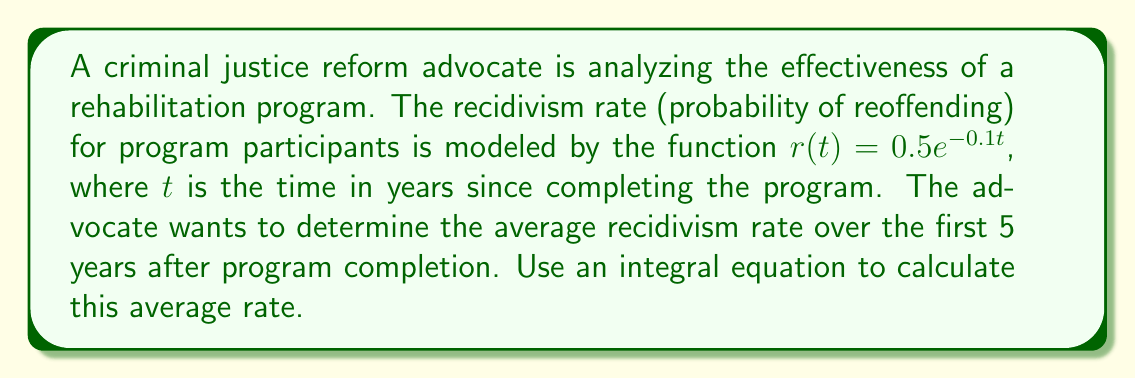Can you solve this math problem? To solve this problem, we need to use the concept of average value of a function over an interval. The formula for the average value of a function $f(x)$ over an interval $[a,b]$ is:

$$\text{Average} = \frac{1}{b-a} \int_a^b f(x) dx$$

In our case:
1) The function is $r(t) = 0.5e^{-0.1t}$
2) The interval is $[0,5]$ (5 years)

Let's set up the integral equation:

$$\text{Average recidivism rate} = \frac{1}{5-0} \int_0^5 0.5e^{-0.1t} dt$$

Now, let's solve the integral:

$$\begin{align}
\frac{1}{5} \int_0^5 0.5e^{-0.1t} dt &= \frac{1}{5} \cdot 0.5 \int_0^5 e^{-0.1t} dt \\
&= \frac{1}{10} \left[ -10e^{-0.1t} \right]_0^5 \\
&= \frac{1}{10} \left[ (-10e^{-0.5}) - (-10e^0) \right] \\
&= \frac{1}{10} \left[ -10e^{-0.5} + 10 \right] \\
&= 1 - e^{-0.5}
\end{align}$$

Therefore, the average recidivism rate over the first 5 years is $1 - e^{-0.5}$.
Answer: $1 - e^{-0.5}$ 